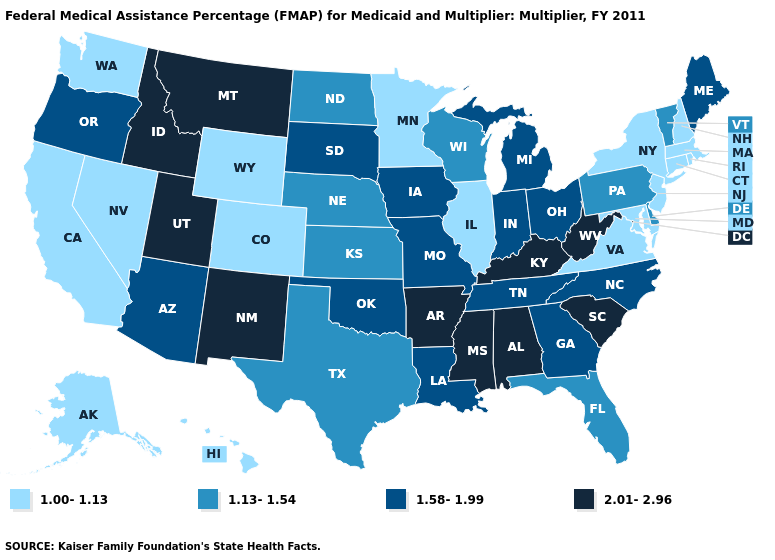What is the value of Kansas?
Answer briefly. 1.13-1.54. Name the states that have a value in the range 1.13-1.54?
Keep it brief. Delaware, Florida, Kansas, Nebraska, North Dakota, Pennsylvania, Texas, Vermont, Wisconsin. What is the highest value in the Northeast ?
Keep it brief. 1.58-1.99. Does Wyoming have a lower value than Nevada?
Write a very short answer. No. Does the map have missing data?
Answer briefly. No. What is the lowest value in the USA?
Be succinct. 1.00-1.13. Name the states that have a value in the range 1.13-1.54?
Quick response, please. Delaware, Florida, Kansas, Nebraska, North Dakota, Pennsylvania, Texas, Vermont, Wisconsin. Does the first symbol in the legend represent the smallest category?
Keep it brief. Yes. What is the value of Florida?
Be succinct. 1.13-1.54. What is the value of Tennessee?
Quick response, please. 1.58-1.99. Which states have the lowest value in the MidWest?
Be succinct. Illinois, Minnesota. Which states hav the highest value in the South?
Concise answer only. Alabama, Arkansas, Kentucky, Mississippi, South Carolina, West Virginia. What is the value of Montana?
Keep it brief. 2.01-2.96. Name the states that have a value in the range 1.58-1.99?
Keep it brief. Arizona, Georgia, Indiana, Iowa, Louisiana, Maine, Michigan, Missouri, North Carolina, Ohio, Oklahoma, Oregon, South Dakota, Tennessee. Name the states that have a value in the range 1.00-1.13?
Answer briefly. Alaska, California, Colorado, Connecticut, Hawaii, Illinois, Maryland, Massachusetts, Minnesota, Nevada, New Hampshire, New Jersey, New York, Rhode Island, Virginia, Washington, Wyoming. 